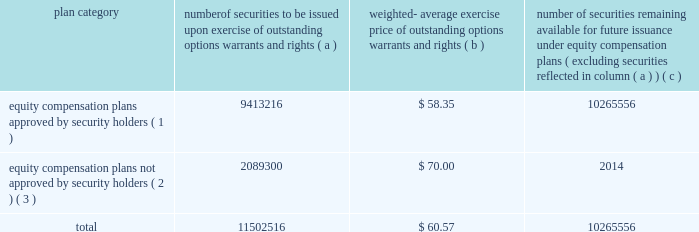Equity compensation plan information the plan documents for the plans described in the footnotes below are included as exhibits to this form 10-k , and are incorporated herein by reference in their entirety .
The table provides information as of dec .
31 , 2006 regarding the number of shares of ppg common stock that may be issued under ppg 2019s equity compensation plans .
Plan category securities exercise of outstanding options , warrants and rights weighted- average exercise price of outstanding warrants and rights number of securities remaining available for future issuance under equity compensation ( excluding securities reflected in column ( a ) ) equity compensation plans approved by security holders ( 1 ) 9413216 $ 58.35 10265556 equity compensation plans not approved by security holders ( 2 ) , ( 3 ) 2089300 $ 70.00 2014 .
( 1 ) equity compensation plans approved by security holders include the ppg industries , inc .
Stock plan , the ppg omnibus plan , the ppg industries , inc .
Executive officers 2019 long term incentive plan , and the ppg industries inc .
Long term incentive plan .
( 2 ) equity compensation plans not approved by security holders include the ppg industries , inc .
Challenge 2000 stock plan .
This plan is a broad- based stock option plan under which the company granted to substantially all active employees of the company and its majority owned subsidiaries on july 1 , 1998 , the option to purchase 100 shares of the company 2019s common stock at its then fair market value of $ 70.00 per share .
Options became exercisable on july 1 , 2003 , and expire on june 30 , 2008 .
There were 2089300 shares issuable upon exercise of options outstanding under this plan as of dec .
31 , 2006 .
( 3 ) excluded from the information presented here are common stock equivalents held under the ppg industries , inc .
Deferred compensation plan , the ppg industries , inc .
Deferred compensation plan for directors and the ppg industries , inc .
Directors 2019 common stock plan , none of which are equity compensation plans .
As supplemental information , there were 491168 common stock equivalents held under such plans as of dec .
31 , 2006 .
Item 6 .
Selected financial data the information required by item 6 regarding the selected financial data for the five years ended dec .
31 , 2006 is included in exhibit 99.2 filed with this form 10-k and is incorporated herein by reference .
This information is also reported in the eleven-year digest on page 72 of the annual report under the captions net sales , income ( loss ) before accounting changes , cumulative effect of accounting changes , net income ( loss ) , earnings ( loss ) per common share before accounting changes , cumulative effect of accounting changes on earnings ( loss ) per common share , earnings ( loss ) per common share , earnings ( loss ) per common share 2013 assuming dilution , dividends per share , total assets and long-term debt for the years 2002 through 2006 .
Item 7 .
Management 2019s discussion and analysis of financial condition and results of operations performance in 2006 compared with 2005 performance overview our sales increased 8% ( 8 % ) to $ 11.0 billion in 2006 compared to $ 10.2 billion in 2005 .
Sales increased 4% ( 4 % ) due to the impact of acquisitions , 2% ( 2 % ) due to increased volumes , and 2% ( 2 % ) due to increased selling prices .
Cost of sales as a percentage of sales increased slightly to 63.7% ( 63.7 % ) compared to 63.5% ( 63.5 % ) in 2005 .
Selling , general and administrative expense increased slightly as a percentage of sales to 17.9% ( 17.9 % ) compared to 17.4% ( 17.4 % ) in 2005 .
These costs increased primarily due to higher expenses related to store expansions in our architectural coatings operating segment and increased advertising to promote growth in our optical products operating segment .
Other charges decreased $ 81 million in 2006 .
Other charges in 2006 included pretax charges of $ 185 million for estimated environmental remediation costs at sites in new jersey and $ 42 million for legal settlements offset in part by pretax earnings of $ 44 million for insurance recoveries related to the marvin legal settlement and to hurricane rita .
Other charges in 2005 included pretax charges of $ 132 million related to the marvin legal settlement net of related insurance recoveries of $ 18 million , $ 61 million for the federal glass class action antitrust legal settlement , $ 34 million of direct costs related to the impact of hurricanes rita and katrina , $ 27 million for an asset impairment charge in our fine chemicals operating segment and $ 19 million for debt refinancing costs .
Other earnings increased $ 30 million in 2006 due to higher equity earnings , primarily from our asian fiber glass joint ventures , and higher royalty income .
Net income and earnings per share 2013 assuming dilution for 2006 were $ 711 million and $ 4.27 , respectively , compared to $ 596 million and $ 3.49 , respectively , for 2005 .
Net income in 2006 included aftertax charges of $ 106 million , or 64 cents a share , for estimated environmental remediation costs at sites in new jersey and louisiana in the third quarter ; $ 26 million , or 15 cents a share , for legal settlements ; $ 23 million , or 14 cents a share for business restructuring ; $ 17 million , or 10 cents a share , to reflect the net increase in the current value of the company 2019s obligation relating to asbestos claims under the ppg settlement arrangement ; and aftertax earnings of $ 24 million , or 14 cents a share for insurance recoveries .
Net income in 2005 included aftertax charges of $ 117 million , or 68 cents a share for legal settlements net of insurance ; $ 21 million , or 12 cents a share for direct costs related to the impact of hurricanes katrina and rita ; $ 17 million , or 10 cents a share , related to an asset impairment charge related to our fine chemicals operating segment ; $ 12 million , or 7 cents a share , for debt refinancing cost ; and $ 13 million , or 8 cents a share , to reflect the net increase in the current 2006 ppg annual report and form 10-k 19 4282_txt to be issued options , number of .
What was the percentage change in earnings per share from 2005 to 2006? 
Computations: ((4.27 - 3.49) / 3.49)
Answer: 0.2235. 